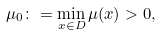<formula> <loc_0><loc_0><loc_500><loc_500>\mu _ { 0 } \colon = \min _ { x \in D } \mu ( x ) > 0 ,</formula> 